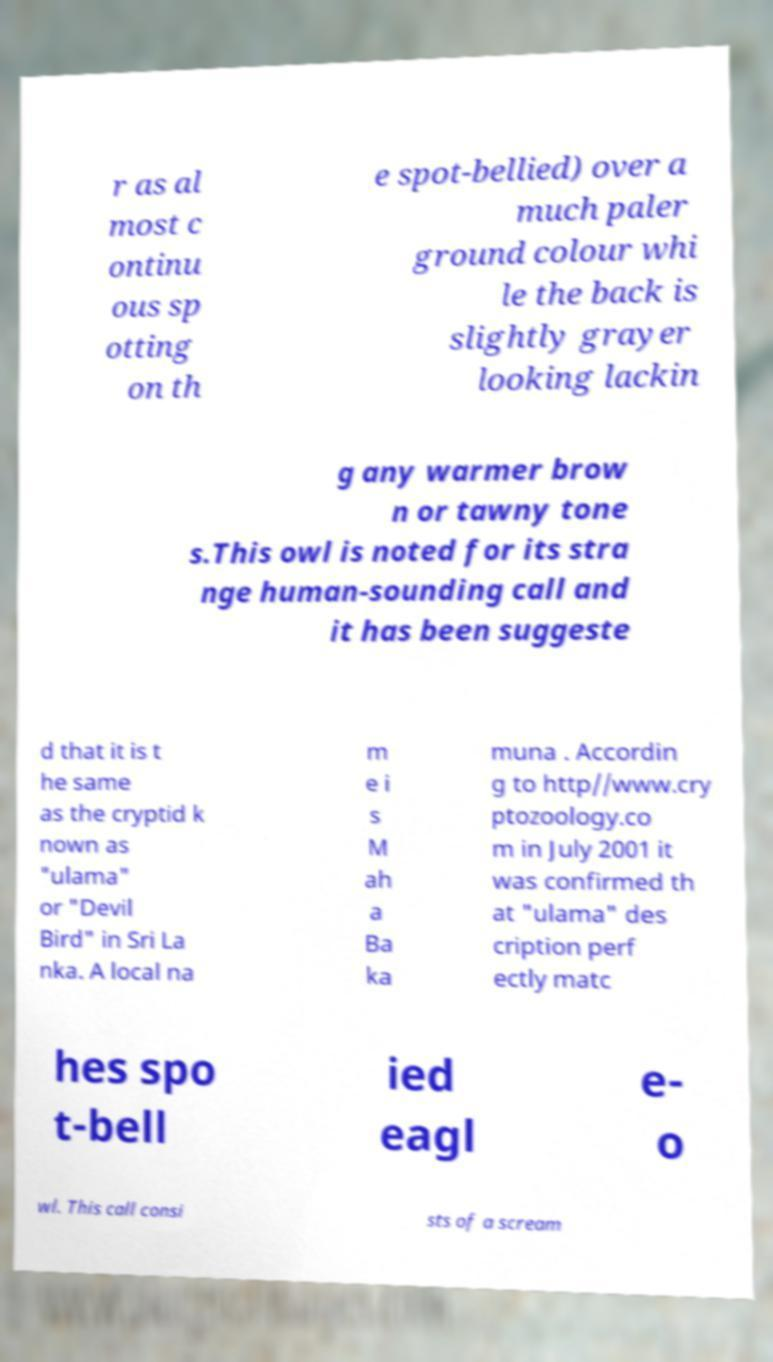Please identify and transcribe the text found in this image. r as al most c ontinu ous sp otting on th e spot-bellied) over a much paler ground colour whi le the back is slightly grayer looking lackin g any warmer brow n or tawny tone s.This owl is noted for its stra nge human-sounding call and it has been suggeste d that it is t he same as the cryptid k nown as "ulama" or "Devil Bird" in Sri La nka. A local na m e i s M ah a Ba ka muna . Accordin g to http//www.cry ptozoology.co m in July 2001 it was confirmed th at "ulama" des cription perf ectly matc hes spo t-bell ied eagl e- o wl. This call consi sts of a scream 